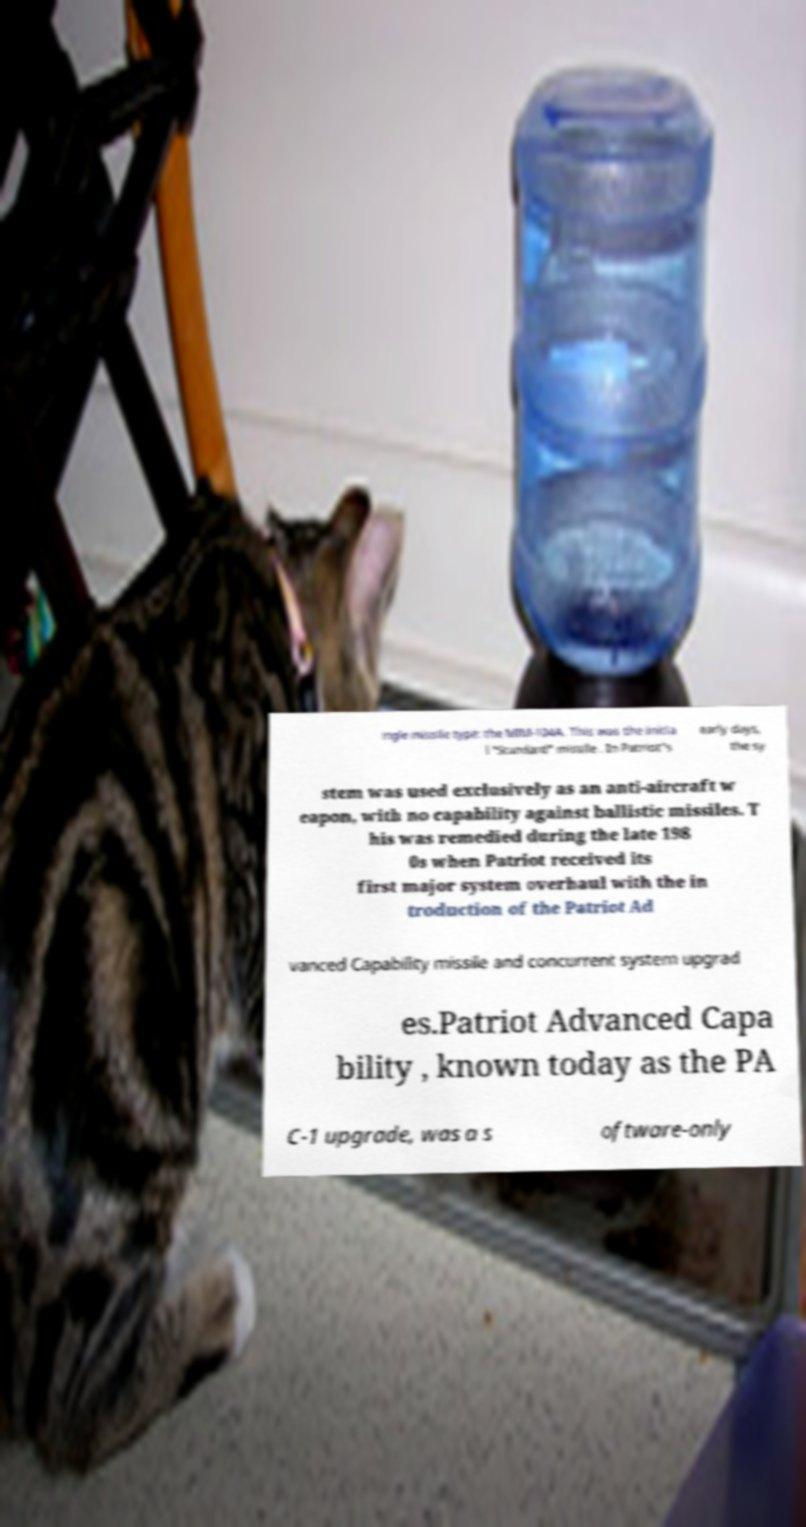Can you accurately transcribe the text from the provided image for me? ingle missile type: the MIM-104A. This was the initia l "Standard" missile . In Patriot's early days, the sy stem was used exclusively as an anti-aircraft w eapon, with no capability against ballistic missiles. T his was remedied during the late 198 0s when Patriot received its first major system overhaul with the in troduction of the Patriot Ad vanced Capability missile and concurrent system upgrad es.Patriot Advanced Capa bility , known today as the PA C-1 upgrade, was a s oftware-only 